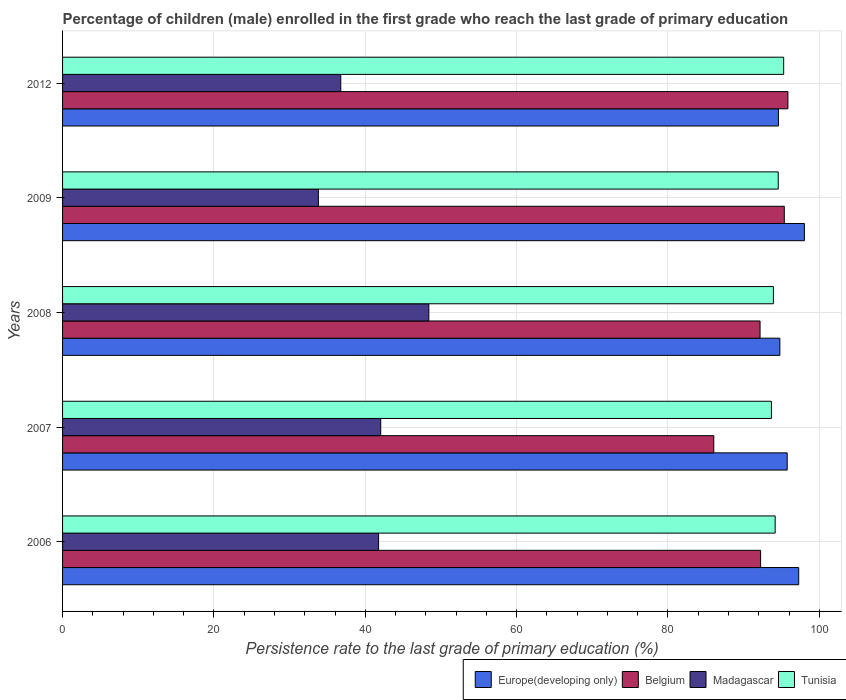How many different coloured bars are there?
Keep it short and to the point. 4. How many groups of bars are there?
Provide a short and direct response. 5. Are the number of bars per tick equal to the number of legend labels?
Give a very brief answer. Yes. What is the label of the 5th group of bars from the top?
Ensure brevity in your answer.  2006. In how many cases, is the number of bars for a given year not equal to the number of legend labels?
Ensure brevity in your answer.  0. What is the persistence rate of children in Europe(developing only) in 2008?
Give a very brief answer. 94.78. Across all years, what is the maximum persistence rate of children in Europe(developing only)?
Your response must be concise. 98.03. Across all years, what is the minimum persistence rate of children in Madagascar?
Give a very brief answer. 33.8. What is the total persistence rate of children in Europe(developing only) in the graph?
Provide a short and direct response. 480.44. What is the difference between the persistence rate of children in Tunisia in 2006 and that in 2008?
Offer a terse response. 0.23. What is the difference between the persistence rate of children in Europe(developing only) in 2009 and the persistence rate of children in Belgium in 2008?
Give a very brief answer. 5.86. What is the average persistence rate of children in Madagascar per year?
Your answer should be compact. 40.55. In the year 2012, what is the difference between the persistence rate of children in Tunisia and persistence rate of children in Belgium?
Your answer should be compact. -0.56. What is the ratio of the persistence rate of children in Europe(developing only) in 2007 to that in 2012?
Provide a short and direct response. 1.01. What is the difference between the highest and the second highest persistence rate of children in Tunisia?
Offer a very short reply. 0.72. What is the difference between the highest and the lowest persistence rate of children in Tunisia?
Your response must be concise. 1.62. In how many years, is the persistence rate of children in Europe(developing only) greater than the average persistence rate of children in Europe(developing only) taken over all years?
Give a very brief answer. 2. Is the sum of the persistence rate of children in Belgium in 2007 and 2008 greater than the maximum persistence rate of children in Tunisia across all years?
Provide a short and direct response. Yes. What does the 1st bar from the top in 2007 represents?
Keep it short and to the point. Tunisia. What does the 4th bar from the bottom in 2007 represents?
Give a very brief answer. Tunisia. Is it the case that in every year, the sum of the persistence rate of children in Europe(developing only) and persistence rate of children in Belgium is greater than the persistence rate of children in Madagascar?
Give a very brief answer. Yes. How many years are there in the graph?
Offer a very short reply. 5. Where does the legend appear in the graph?
Provide a short and direct response. Bottom right. How many legend labels are there?
Keep it short and to the point. 4. How are the legend labels stacked?
Make the answer very short. Horizontal. What is the title of the graph?
Your response must be concise. Percentage of children (male) enrolled in the first grade who reach the last grade of primary education. Does "Japan" appear as one of the legend labels in the graph?
Provide a succinct answer. No. What is the label or title of the X-axis?
Your response must be concise. Persistence rate to the last grade of primary education (%). What is the Persistence rate to the last grade of primary education (%) of Europe(developing only) in 2006?
Offer a terse response. 97.27. What is the Persistence rate to the last grade of primary education (%) of Belgium in 2006?
Provide a succinct answer. 92.24. What is the Persistence rate to the last grade of primary education (%) in Madagascar in 2006?
Your answer should be compact. 41.76. What is the Persistence rate to the last grade of primary education (%) of Tunisia in 2006?
Your answer should be compact. 94.17. What is the Persistence rate to the last grade of primary education (%) in Europe(developing only) in 2007?
Offer a terse response. 95.75. What is the Persistence rate to the last grade of primary education (%) of Belgium in 2007?
Ensure brevity in your answer.  86.05. What is the Persistence rate to the last grade of primary education (%) of Madagascar in 2007?
Ensure brevity in your answer.  42.04. What is the Persistence rate to the last grade of primary education (%) in Tunisia in 2007?
Give a very brief answer. 93.67. What is the Persistence rate to the last grade of primary education (%) in Europe(developing only) in 2008?
Give a very brief answer. 94.78. What is the Persistence rate to the last grade of primary education (%) in Belgium in 2008?
Offer a very short reply. 92.17. What is the Persistence rate to the last grade of primary education (%) of Madagascar in 2008?
Keep it short and to the point. 48.4. What is the Persistence rate to the last grade of primary education (%) of Tunisia in 2008?
Your answer should be compact. 93.93. What is the Persistence rate to the last grade of primary education (%) in Europe(developing only) in 2009?
Ensure brevity in your answer.  98.03. What is the Persistence rate to the last grade of primary education (%) in Belgium in 2009?
Provide a short and direct response. 95.37. What is the Persistence rate to the last grade of primary education (%) of Madagascar in 2009?
Ensure brevity in your answer.  33.8. What is the Persistence rate to the last grade of primary education (%) of Tunisia in 2009?
Give a very brief answer. 94.57. What is the Persistence rate to the last grade of primary education (%) of Europe(developing only) in 2012?
Give a very brief answer. 94.6. What is the Persistence rate to the last grade of primary education (%) in Belgium in 2012?
Make the answer very short. 95.85. What is the Persistence rate to the last grade of primary education (%) of Madagascar in 2012?
Offer a terse response. 36.76. What is the Persistence rate to the last grade of primary education (%) of Tunisia in 2012?
Offer a terse response. 95.29. Across all years, what is the maximum Persistence rate to the last grade of primary education (%) of Europe(developing only)?
Your answer should be compact. 98.03. Across all years, what is the maximum Persistence rate to the last grade of primary education (%) of Belgium?
Offer a very short reply. 95.85. Across all years, what is the maximum Persistence rate to the last grade of primary education (%) of Madagascar?
Give a very brief answer. 48.4. Across all years, what is the maximum Persistence rate to the last grade of primary education (%) in Tunisia?
Make the answer very short. 95.29. Across all years, what is the minimum Persistence rate to the last grade of primary education (%) in Europe(developing only)?
Your answer should be compact. 94.6. Across all years, what is the minimum Persistence rate to the last grade of primary education (%) of Belgium?
Give a very brief answer. 86.05. Across all years, what is the minimum Persistence rate to the last grade of primary education (%) in Madagascar?
Make the answer very short. 33.8. Across all years, what is the minimum Persistence rate to the last grade of primary education (%) in Tunisia?
Ensure brevity in your answer.  93.67. What is the total Persistence rate to the last grade of primary education (%) in Europe(developing only) in the graph?
Give a very brief answer. 480.44. What is the total Persistence rate to the last grade of primary education (%) in Belgium in the graph?
Your answer should be compact. 461.68. What is the total Persistence rate to the last grade of primary education (%) in Madagascar in the graph?
Keep it short and to the point. 202.77. What is the total Persistence rate to the last grade of primary education (%) in Tunisia in the graph?
Your answer should be very brief. 471.63. What is the difference between the Persistence rate to the last grade of primary education (%) of Europe(developing only) in 2006 and that in 2007?
Make the answer very short. 1.52. What is the difference between the Persistence rate to the last grade of primary education (%) in Belgium in 2006 and that in 2007?
Ensure brevity in your answer.  6.19. What is the difference between the Persistence rate to the last grade of primary education (%) in Madagascar in 2006 and that in 2007?
Provide a short and direct response. -0.28. What is the difference between the Persistence rate to the last grade of primary education (%) of Tunisia in 2006 and that in 2007?
Offer a terse response. 0.5. What is the difference between the Persistence rate to the last grade of primary education (%) of Europe(developing only) in 2006 and that in 2008?
Offer a terse response. 2.49. What is the difference between the Persistence rate to the last grade of primary education (%) in Belgium in 2006 and that in 2008?
Provide a short and direct response. 0.07. What is the difference between the Persistence rate to the last grade of primary education (%) of Madagascar in 2006 and that in 2008?
Offer a terse response. -6.64. What is the difference between the Persistence rate to the last grade of primary education (%) in Tunisia in 2006 and that in 2008?
Provide a short and direct response. 0.23. What is the difference between the Persistence rate to the last grade of primary education (%) of Europe(developing only) in 2006 and that in 2009?
Your response must be concise. -0.75. What is the difference between the Persistence rate to the last grade of primary education (%) in Belgium in 2006 and that in 2009?
Keep it short and to the point. -3.13. What is the difference between the Persistence rate to the last grade of primary education (%) in Madagascar in 2006 and that in 2009?
Offer a terse response. 7.96. What is the difference between the Persistence rate to the last grade of primary education (%) of Tunisia in 2006 and that in 2009?
Offer a very short reply. -0.4. What is the difference between the Persistence rate to the last grade of primary education (%) of Europe(developing only) in 2006 and that in 2012?
Your answer should be very brief. 2.68. What is the difference between the Persistence rate to the last grade of primary education (%) of Belgium in 2006 and that in 2012?
Keep it short and to the point. -3.61. What is the difference between the Persistence rate to the last grade of primary education (%) in Madagascar in 2006 and that in 2012?
Offer a very short reply. 5. What is the difference between the Persistence rate to the last grade of primary education (%) of Tunisia in 2006 and that in 2012?
Keep it short and to the point. -1.12. What is the difference between the Persistence rate to the last grade of primary education (%) of Europe(developing only) in 2007 and that in 2008?
Provide a short and direct response. 0.97. What is the difference between the Persistence rate to the last grade of primary education (%) of Belgium in 2007 and that in 2008?
Offer a very short reply. -6.11. What is the difference between the Persistence rate to the last grade of primary education (%) of Madagascar in 2007 and that in 2008?
Ensure brevity in your answer.  -6.36. What is the difference between the Persistence rate to the last grade of primary education (%) in Tunisia in 2007 and that in 2008?
Ensure brevity in your answer.  -0.26. What is the difference between the Persistence rate to the last grade of primary education (%) of Europe(developing only) in 2007 and that in 2009?
Your response must be concise. -2.27. What is the difference between the Persistence rate to the last grade of primary education (%) in Belgium in 2007 and that in 2009?
Ensure brevity in your answer.  -9.32. What is the difference between the Persistence rate to the last grade of primary education (%) in Madagascar in 2007 and that in 2009?
Make the answer very short. 8.24. What is the difference between the Persistence rate to the last grade of primary education (%) in Tunisia in 2007 and that in 2009?
Keep it short and to the point. -0.9. What is the difference between the Persistence rate to the last grade of primary education (%) in Europe(developing only) in 2007 and that in 2012?
Your answer should be very brief. 1.16. What is the difference between the Persistence rate to the last grade of primary education (%) in Belgium in 2007 and that in 2012?
Offer a terse response. -9.8. What is the difference between the Persistence rate to the last grade of primary education (%) in Madagascar in 2007 and that in 2012?
Give a very brief answer. 5.28. What is the difference between the Persistence rate to the last grade of primary education (%) of Tunisia in 2007 and that in 2012?
Ensure brevity in your answer.  -1.62. What is the difference between the Persistence rate to the last grade of primary education (%) in Europe(developing only) in 2008 and that in 2009?
Keep it short and to the point. -3.24. What is the difference between the Persistence rate to the last grade of primary education (%) of Belgium in 2008 and that in 2009?
Make the answer very short. -3.2. What is the difference between the Persistence rate to the last grade of primary education (%) in Madagascar in 2008 and that in 2009?
Provide a short and direct response. 14.6. What is the difference between the Persistence rate to the last grade of primary education (%) of Tunisia in 2008 and that in 2009?
Make the answer very short. -0.64. What is the difference between the Persistence rate to the last grade of primary education (%) of Europe(developing only) in 2008 and that in 2012?
Keep it short and to the point. 0.19. What is the difference between the Persistence rate to the last grade of primary education (%) in Belgium in 2008 and that in 2012?
Give a very brief answer. -3.68. What is the difference between the Persistence rate to the last grade of primary education (%) in Madagascar in 2008 and that in 2012?
Offer a very short reply. 11.64. What is the difference between the Persistence rate to the last grade of primary education (%) of Tunisia in 2008 and that in 2012?
Keep it short and to the point. -1.36. What is the difference between the Persistence rate to the last grade of primary education (%) in Europe(developing only) in 2009 and that in 2012?
Give a very brief answer. 3.43. What is the difference between the Persistence rate to the last grade of primary education (%) of Belgium in 2009 and that in 2012?
Your response must be concise. -0.48. What is the difference between the Persistence rate to the last grade of primary education (%) in Madagascar in 2009 and that in 2012?
Keep it short and to the point. -2.96. What is the difference between the Persistence rate to the last grade of primary education (%) in Tunisia in 2009 and that in 2012?
Provide a short and direct response. -0.72. What is the difference between the Persistence rate to the last grade of primary education (%) in Europe(developing only) in 2006 and the Persistence rate to the last grade of primary education (%) in Belgium in 2007?
Provide a short and direct response. 11.22. What is the difference between the Persistence rate to the last grade of primary education (%) of Europe(developing only) in 2006 and the Persistence rate to the last grade of primary education (%) of Madagascar in 2007?
Ensure brevity in your answer.  55.23. What is the difference between the Persistence rate to the last grade of primary education (%) in Europe(developing only) in 2006 and the Persistence rate to the last grade of primary education (%) in Tunisia in 2007?
Your answer should be compact. 3.6. What is the difference between the Persistence rate to the last grade of primary education (%) of Belgium in 2006 and the Persistence rate to the last grade of primary education (%) of Madagascar in 2007?
Offer a very short reply. 50.2. What is the difference between the Persistence rate to the last grade of primary education (%) of Belgium in 2006 and the Persistence rate to the last grade of primary education (%) of Tunisia in 2007?
Your response must be concise. -1.43. What is the difference between the Persistence rate to the last grade of primary education (%) of Madagascar in 2006 and the Persistence rate to the last grade of primary education (%) of Tunisia in 2007?
Give a very brief answer. -51.91. What is the difference between the Persistence rate to the last grade of primary education (%) in Europe(developing only) in 2006 and the Persistence rate to the last grade of primary education (%) in Belgium in 2008?
Offer a very short reply. 5.11. What is the difference between the Persistence rate to the last grade of primary education (%) of Europe(developing only) in 2006 and the Persistence rate to the last grade of primary education (%) of Madagascar in 2008?
Your answer should be compact. 48.87. What is the difference between the Persistence rate to the last grade of primary education (%) of Europe(developing only) in 2006 and the Persistence rate to the last grade of primary education (%) of Tunisia in 2008?
Offer a very short reply. 3.34. What is the difference between the Persistence rate to the last grade of primary education (%) of Belgium in 2006 and the Persistence rate to the last grade of primary education (%) of Madagascar in 2008?
Ensure brevity in your answer.  43.84. What is the difference between the Persistence rate to the last grade of primary education (%) of Belgium in 2006 and the Persistence rate to the last grade of primary education (%) of Tunisia in 2008?
Give a very brief answer. -1.69. What is the difference between the Persistence rate to the last grade of primary education (%) in Madagascar in 2006 and the Persistence rate to the last grade of primary education (%) in Tunisia in 2008?
Provide a short and direct response. -52.17. What is the difference between the Persistence rate to the last grade of primary education (%) in Europe(developing only) in 2006 and the Persistence rate to the last grade of primary education (%) in Belgium in 2009?
Offer a terse response. 1.9. What is the difference between the Persistence rate to the last grade of primary education (%) of Europe(developing only) in 2006 and the Persistence rate to the last grade of primary education (%) of Madagascar in 2009?
Your answer should be very brief. 63.47. What is the difference between the Persistence rate to the last grade of primary education (%) of Europe(developing only) in 2006 and the Persistence rate to the last grade of primary education (%) of Tunisia in 2009?
Offer a very short reply. 2.7. What is the difference between the Persistence rate to the last grade of primary education (%) of Belgium in 2006 and the Persistence rate to the last grade of primary education (%) of Madagascar in 2009?
Provide a succinct answer. 58.44. What is the difference between the Persistence rate to the last grade of primary education (%) of Belgium in 2006 and the Persistence rate to the last grade of primary education (%) of Tunisia in 2009?
Your answer should be compact. -2.33. What is the difference between the Persistence rate to the last grade of primary education (%) in Madagascar in 2006 and the Persistence rate to the last grade of primary education (%) in Tunisia in 2009?
Provide a short and direct response. -52.81. What is the difference between the Persistence rate to the last grade of primary education (%) of Europe(developing only) in 2006 and the Persistence rate to the last grade of primary education (%) of Belgium in 2012?
Make the answer very short. 1.43. What is the difference between the Persistence rate to the last grade of primary education (%) in Europe(developing only) in 2006 and the Persistence rate to the last grade of primary education (%) in Madagascar in 2012?
Provide a short and direct response. 60.51. What is the difference between the Persistence rate to the last grade of primary education (%) of Europe(developing only) in 2006 and the Persistence rate to the last grade of primary education (%) of Tunisia in 2012?
Give a very brief answer. 1.99. What is the difference between the Persistence rate to the last grade of primary education (%) in Belgium in 2006 and the Persistence rate to the last grade of primary education (%) in Madagascar in 2012?
Provide a succinct answer. 55.48. What is the difference between the Persistence rate to the last grade of primary education (%) in Belgium in 2006 and the Persistence rate to the last grade of primary education (%) in Tunisia in 2012?
Provide a short and direct response. -3.05. What is the difference between the Persistence rate to the last grade of primary education (%) of Madagascar in 2006 and the Persistence rate to the last grade of primary education (%) of Tunisia in 2012?
Your answer should be very brief. -53.53. What is the difference between the Persistence rate to the last grade of primary education (%) in Europe(developing only) in 2007 and the Persistence rate to the last grade of primary education (%) in Belgium in 2008?
Keep it short and to the point. 3.59. What is the difference between the Persistence rate to the last grade of primary education (%) of Europe(developing only) in 2007 and the Persistence rate to the last grade of primary education (%) of Madagascar in 2008?
Keep it short and to the point. 47.35. What is the difference between the Persistence rate to the last grade of primary education (%) of Europe(developing only) in 2007 and the Persistence rate to the last grade of primary education (%) of Tunisia in 2008?
Offer a very short reply. 1.82. What is the difference between the Persistence rate to the last grade of primary education (%) in Belgium in 2007 and the Persistence rate to the last grade of primary education (%) in Madagascar in 2008?
Give a very brief answer. 37.65. What is the difference between the Persistence rate to the last grade of primary education (%) of Belgium in 2007 and the Persistence rate to the last grade of primary education (%) of Tunisia in 2008?
Your response must be concise. -7.88. What is the difference between the Persistence rate to the last grade of primary education (%) in Madagascar in 2007 and the Persistence rate to the last grade of primary education (%) in Tunisia in 2008?
Provide a short and direct response. -51.89. What is the difference between the Persistence rate to the last grade of primary education (%) of Europe(developing only) in 2007 and the Persistence rate to the last grade of primary education (%) of Belgium in 2009?
Ensure brevity in your answer.  0.38. What is the difference between the Persistence rate to the last grade of primary education (%) in Europe(developing only) in 2007 and the Persistence rate to the last grade of primary education (%) in Madagascar in 2009?
Keep it short and to the point. 61.95. What is the difference between the Persistence rate to the last grade of primary education (%) of Europe(developing only) in 2007 and the Persistence rate to the last grade of primary education (%) of Tunisia in 2009?
Your response must be concise. 1.18. What is the difference between the Persistence rate to the last grade of primary education (%) of Belgium in 2007 and the Persistence rate to the last grade of primary education (%) of Madagascar in 2009?
Your answer should be very brief. 52.25. What is the difference between the Persistence rate to the last grade of primary education (%) in Belgium in 2007 and the Persistence rate to the last grade of primary education (%) in Tunisia in 2009?
Offer a very short reply. -8.52. What is the difference between the Persistence rate to the last grade of primary education (%) of Madagascar in 2007 and the Persistence rate to the last grade of primary education (%) of Tunisia in 2009?
Give a very brief answer. -52.53. What is the difference between the Persistence rate to the last grade of primary education (%) in Europe(developing only) in 2007 and the Persistence rate to the last grade of primary education (%) in Belgium in 2012?
Your answer should be compact. -0.09. What is the difference between the Persistence rate to the last grade of primary education (%) of Europe(developing only) in 2007 and the Persistence rate to the last grade of primary education (%) of Madagascar in 2012?
Your answer should be very brief. 58.99. What is the difference between the Persistence rate to the last grade of primary education (%) of Europe(developing only) in 2007 and the Persistence rate to the last grade of primary education (%) of Tunisia in 2012?
Give a very brief answer. 0.47. What is the difference between the Persistence rate to the last grade of primary education (%) in Belgium in 2007 and the Persistence rate to the last grade of primary education (%) in Madagascar in 2012?
Give a very brief answer. 49.29. What is the difference between the Persistence rate to the last grade of primary education (%) of Belgium in 2007 and the Persistence rate to the last grade of primary education (%) of Tunisia in 2012?
Keep it short and to the point. -9.24. What is the difference between the Persistence rate to the last grade of primary education (%) in Madagascar in 2007 and the Persistence rate to the last grade of primary education (%) in Tunisia in 2012?
Your answer should be compact. -53.25. What is the difference between the Persistence rate to the last grade of primary education (%) in Europe(developing only) in 2008 and the Persistence rate to the last grade of primary education (%) in Belgium in 2009?
Your answer should be compact. -0.59. What is the difference between the Persistence rate to the last grade of primary education (%) of Europe(developing only) in 2008 and the Persistence rate to the last grade of primary education (%) of Madagascar in 2009?
Ensure brevity in your answer.  60.98. What is the difference between the Persistence rate to the last grade of primary education (%) of Europe(developing only) in 2008 and the Persistence rate to the last grade of primary education (%) of Tunisia in 2009?
Ensure brevity in your answer.  0.21. What is the difference between the Persistence rate to the last grade of primary education (%) of Belgium in 2008 and the Persistence rate to the last grade of primary education (%) of Madagascar in 2009?
Offer a very short reply. 58.36. What is the difference between the Persistence rate to the last grade of primary education (%) of Belgium in 2008 and the Persistence rate to the last grade of primary education (%) of Tunisia in 2009?
Your answer should be very brief. -2.4. What is the difference between the Persistence rate to the last grade of primary education (%) of Madagascar in 2008 and the Persistence rate to the last grade of primary education (%) of Tunisia in 2009?
Provide a short and direct response. -46.17. What is the difference between the Persistence rate to the last grade of primary education (%) of Europe(developing only) in 2008 and the Persistence rate to the last grade of primary education (%) of Belgium in 2012?
Give a very brief answer. -1.06. What is the difference between the Persistence rate to the last grade of primary education (%) in Europe(developing only) in 2008 and the Persistence rate to the last grade of primary education (%) in Madagascar in 2012?
Your answer should be very brief. 58.02. What is the difference between the Persistence rate to the last grade of primary education (%) in Europe(developing only) in 2008 and the Persistence rate to the last grade of primary education (%) in Tunisia in 2012?
Your response must be concise. -0.51. What is the difference between the Persistence rate to the last grade of primary education (%) in Belgium in 2008 and the Persistence rate to the last grade of primary education (%) in Madagascar in 2012?
Ensure brevity in your answer.  55.41. What is the difference between the Persistence rate to the last grade of primary education (%) of Belgium in 2008 and the Persistence rate to the last grade of primary education (%) of Tunisia in 2012?
Offer a very short reply. -3.12. What is the difference between the Persistence rate to the last grade of primary education (%) of Madagascar in 2008 and the Persistence rate to the last grade of primary education (%) of Tunisia in 2012?
Your response must be concise. -46.89. What is the difference between the Persistence rate to the last grade of primary education (%) in Europe(developing only) in 2009 and the Persistence rate to the last grade of primary education (%) in Belgium in 2012?
Ensure brevity in your answer.  2.18. What is the difference between the Persistence rate to the last grade of primary education (%) of Europe(developing only) in 2009 and the Persistence rate to the last grade of primary education (%) of Madagascar in 2012?
Ensure brevity in your answer.  61.26. What is the difference between the Persistence rate to the last grade of primary education (%) in Europe(developing only) in 2009 and the Persistence rate to the last grade of primary education (%) in Tunisia in 2012?
Ensure brevity in your answer.  2.74. What is the difference between the Persistence rate to the last grade of primary education (%) of Belgium in 2009 and the Persistence rate to the last grade of primary education (%) of Madagascar in 2012?
Keep it short and to the point. 58.61. What is the difference between the Persistence rate to the last grade of primary education (%) in Belgium in 2009 and the Persistence rate to the last grade of primary education (%) in Tunisia in 2012?
Your response must be concise. 0.08. What is the difference between the Persistence rate to the last grade of primary education (%) in Madagascar in 2009 and the Persistence rate to the last grade of primary education (%) in Tunisia in 2012?
Your answer should be compact. -61.48. What is the average Persistence rate to the last grade of primary education (%) in Europe(developing only) per year?
Offer a terse response. 96.09. What is the average Persistence rate to the last grade of primary education (%) in Belgium per year?
Keep it short and to the point. 92.34. What is the average Persistence rate to the last grade of primary education (%) in Madagascar per year?
Your answer should be compact. 40.55. What is the average Persistence rate to the last grade of primary education (%) of Tunisia per year?
Your answer should be compact. 94.33. In the year 2006, what is the difference between the Persistence rate to the last grade of primary education (%) of Europe(developing only) and Persistence rate to the last grade of primary education (%) of Belgium?
Keep it short and to the point. 5.03. In the year 2006, what is the difference between the Persistence rate to the last grade of primary education (%) of Europe(developing only) and Persistence rate to the last grade of primary education (%) of Madagascar?
Ensure brevity in your answer.  55.51. In the year 2006, what is the difference between the Persistence rate to the last grade of primary education (%) in Europe(developing only) and Persistence rate to the last grade of primary education (%) in Tunisia?
Your answer should be very brief. 3.11. In the year 2006, what is the difference between the Persistence rate to the last grade of primary education (%) of Belgium and Persistence rate to the last grade of primary education (%) of Madagascar?
Your answer should be very brief. 50.48. In the year 2006, what is the difference between the Persistence rate to the last grade of primary education (%) of Belgium and Persistence rate to the last grade of primary education (%) of Tunisia?
Provide a short and direct response. -1.92. In the year 2006, what is the difference between the Persistence rate to the last grade of primary education (%) in Madagascar and Persistence rate to the last grade of primary education (%) in Tunisia?
Offer a very short reply. -52.41. In the year 2007, what is the difference between the Persistence rate to the last grade of primary education (%) of Europe(developing only) and Persistence rate to the last grade of primary education (%) of Belgium?
Offer a very short reply. 9.7. In the year 2007, what is the difference between the Persistence rate to the last grade of primary education (%) of Europe(developing only) and Persistence rate to the last grade of primary education (%) of Madagascar?
Give a very brief answer. 53.71. In the year 2007, what is the difference between the Persistence rate to the last grade of primary education (%) in Europe(developing only) and Persistence rate to the last grade of primary education (%) in Tunisia?
Offer a terse response. 2.09. In the year 2007, what is the difference between the Persistence rate to the last grade of primary education (%) of Belgium and Persistence rate to the last grade of primary education (%) of Madagascar?
Your answer should be compact. 44.01. In the year 2007, what is the difference between the Persistence rate to the last grade of primary education (%) in Belgium and Persistence rate to the last grade of primary education (%) in Tunisia?
Offer a terse response. -7.62. In the year 2007, what is the difference between the Persistence rate to the last grade of primary education (%) of Madagascar and Persistence rate to the last grade of primary education (%) of Tunisia?
Offer a very short reply. -51.63. In the year 2008, what is the difference between the Persistence rate to the last grade of primary education (%) in Europe(developing only) and Persistence rate to the last grade of primary education (%) in Belgium?
Provide a succinct answer. 2.62. In the year 2008, what is the difference between the Persistence rate to the last grade of primary education (%) of Europe(developing only) and Persistence rate to the last grade of primary education (%) of Madagascar?
Your answer should be compact. 46.38. In the year 2008, what is the difference between the Persistence rate to the last grade of primary education (%) in Europe(developing only) and Persistence rate to the last grade of primary education (%) in Tunisia?
Provide a succinct answer. 0.85. In the year 2008, what is the difference between the Persistence rate to the last grade of primary education (%) of Belgium and Persistence rate to the last grade of primary education (%) of Madagascar?
Provide a short and direct response. 43.77. In the year 2008, what is the difference between the Persistence rate to the last grade of primary education (%) of Belgium and Persistence rate to the last grade of primary education (%) of Tunisia?
Make the answer very short. -1.76. In the year 2008, what is the difference between the Persistence rate to the last grade of primary education (%) of Madagascar and Persistence rate to the last grade of primary education (%) of Tunisia?
Your response must be concise. -45.53. In the year 2009, what is the difference between the Persistence rate to the last grade of primary education (%) of Europe(developing only) and Persistence rate to the last grade of primary education (%) of Belgium?
Your response must be concise. 2.66. In the year 2009, what is the difference between the Persistence rate to the last grade of primary education (%) in Europe(developing only) and Persistence rate to the last grade of primary education (%) in Madagascar?
Give a very brief answer. 64.22. In the year 2009, what is the difference between the Persistence rate to the last grade of primary education (%) in Europe(developing only) and Persistence rate to the last grade of primary education (%) in Tunisia?
Provide a short and direct response. 3.46. In the year 2009, what is the difference between the Persistence rate to the last grade of primary education (%) of Belgium and Persistence rate to the last grade of primary education (%) of Madagascar?
Give a very brief answer. 61.57. In the year 2009, what is the difference between the Persistence rate to the last grade of primary education (%) in Belgium and Persistence rate to the last grade of primary education (%) in Tunisia?
Provide a short and direct response. 0.8. In the year 2009, what is the difference between the Persistence rate to the last grade of primary education (%) in Madagascar and Persistence rate to the last grade of primary education (%) in Tunisia?
Keep it short and to the point. -60.77. In the year 2012, what is the difference between the Persistence rate to the last grade of primary education (%) in Europe(developing only) and Persistence rate to the last grade of primary education (%) in Belgium?
Your response must be concise. -1.25. In the year 2012, what is the difference between the Persistence rate to the last grade of primary education (%) of Europe(developing only) and Persistence rate to the last grade of primary education (%) of Madagascar?
Keep it short and to the point. 57.84. In the year 2012, what is the difference between the Persistence rate to the last grade of primary education (%) of Europe(developing only) and Persistence rate to the last grade of primary education (%) of Tunisia?
Ensure brevity in your answer.  -0.69. In the year 2012, what is the difference between the Persistence rate to the last grade of primary education (%) of Belgium and Persistence rate to the last grade of primary education (%) of Madagascar?
Offer a very short reply. 59.09. In the year 2012, what is the difference between the Persistence rate to the last grade of primary education (%) in Belgium and Persistence rate to the last grade of primary education (%) in Tunisia?
Offer a terse response. 0.56. In the year 2012, what is the difference between the Persistence rate to the last grade of primary education (%) of Madagascar and Persistence rate to the last grade of primary education (%) of Tunisia?
Keep it short and to the point. -58.53. What is the ratio of the Persistence rate to the last grade of primary education (%) in Europe(developing only) in 2006 to that in 2007?
Ensure brevity in your answer.  1.02. What is the ratio of the Persistence rate to the last grade of primary education (%) in Belgium in 2006 to that in 2007?
Offer a terse response. 1.07. What is the ratio of the Persistence rate to the last grade of primary education (%) of Madagascar in 2006 to that in 2007?
Give a very brief answer. 0.99. What is the ratio of the Persistence rate to the last grade of primary education (%) of Europe(developing only) in 2006 to that in 2008?
Provide a short and direct response. 1.03. What is the ratio of the Persistence rate to the last grade of primary education (%) of Belgium in 2006 to that in 2008?
Offer a terse response. 1. What is the ratio of the Persistence rate to the last grade of primary education (%) of Madagascar in 2006 to that in 2008?
Provide a short and direct response. 0.86. What is the ratio of the Persistence rate to the last grade of primary education (%) in Tunisia in 2006 to that in 2008?
Your answer should be compact. 1. What is the ratio of the Persistence rate to the last grade of primary education (%) in Belgium in 2006 to that in 2009?
Offer a very short reply. 0.97. What is the ratio of the Persistence rate to the last grade of primary education (%) of Madagascar in 2006 to that in 2009?
Provide a short and direct response. 1.24. What is the ratio of the Persistence rate to the last grade of primary education (%) in Europe(developing only) in 2006 to that in 2012?
Offer a terse response. 1.03. What is the ratio of the Persistence rate to the last grade of primary education (%) in Belgium in 2006 to that in 2012?
Your answer should be compact. 0.96. What is the ratio of the Persistence rate to the last grade of primary education (%) in Madagascar in 2006 to that in 2012?
Offer a terse response. 1.14. What is the ratio of the Persistence rate to the last grade of primary education (%) in Tunisia in 2006 to that in 2012?
Give a very brief answer. 0.99. What is the ratio of the Persistence rate to the last grade of primary education (%) of Europe(developing only) in 2007 to that in 2008?
Keep it short and to the point. 1.01. What is the ratio of the Persistence rate to the last grade of primary education (%) in Belgium in 2007 to that in 2008?
Offer a very short reply. 0.93. What is the ratio of the Persistence rate to the last grade of primary education (%) in Madagascar in 2007 to that in 2008?
Ensure brevity in your answer.  0.87. What is the ratio of the Persistence rate to the last grade of primary education (%) of Tunisia in 2007 to that in 2008?
Your answer should be very brief. 1. What is the ratio of the Persistence rate to the last grade of primary education (%) of Europe(developing only) in 2007 to that in 2009?
Your answer should be compact. 0.98. What is the ratio of the Persistence rate to the last grade of primary education (%) in Belgium in 2007 to that in 2009?
Your answer should be compact. 0.9. What is the ratio of the Persistence rate to the last grade of primary education (%) in Madagascar in 2007 to that in 2009?
Provide a succinct answer. 1.24. What is the ratio of the Persistence rate to the last grade of primary education (%) of Tunisia in 2007 to that in 2009?
Your answer should be very brief. 0.99. What is the ratio of the Persistence rate to the last grade of primary education (%) in Europe(developing only) in 2007 to that in 2012?
Make the answer very short. 1.01. What is the ratio of the Persistence rate to the last grade of primary education (%) of Belgium in 2007 to that in 2012?
Your answer should be compact. 0.9. What is the ratio of the Persistence rate to the last grade of primary education (%) of Madagascar in 2007 to that in 2012?
Offer a very short reply. 1.14. What is the ratio of the Persistence rate to the last grade of primary education (%) in Europe(developing only) in 2008 to that in 2009?
Ensure brevity in your answer.  0.97. What is the ratio of the Persistence rate to the last grade of primary education (%) of Belgium in 2008 to that in 2009?
Give a very brief answer. 0.97. What is the ratio of the Persistence rate to the last grade of primary education (%) of Madagascar in 2008 to that in 2009?
Offer a terse response. 1.43. What is the ratio of the Persistence rate to the last grade of primary education (%) of Tunisia in 2008 to that in 2009?
Your response must be concise. 0.99. What is the ratio of the Persistence rate to the last grade of primary education (%) of Europe(developing only) in 2008 to that in 2012?
Make the answer very short. 1. What is the ratio of the Persistence rate to the last grade of primary education (%) of Belgium in 2008 to that in 2012?
Your response must be concise. 0.96. What is the ratio of the Persistence rate to the last grade of primary education (%) in Madagascar in 2008 to that in 2012?
Your answer should be very brief. 1.32. What is the ratio of the Persistence rate to the last grade of primary education (%) of Tunisia in 2008 to that in 2012?
Your answer should be compact. 0.99. What is the ratio of the Persistence rate to the last grade of primary education (%) of Europe(developing only) in 2009 to that in 2012?
Your response must be concise. 1.04. What is the ratio of the Persistence rate to the last grade of primary education (%) in Belgium in 2009 to that in 2012?
Your response must be concise. 0.99. What is the ratio of the Persistence rate to the last grade of primary education (%) of Madagascar in 2009 to that in 2012?
Keep it short and to the point. 0.92. What is the ratio of the Persistence rate to the last grade of primary education (%) of Tunisia in 2009 to that in 2012?
Make the answer very short. 0.99. What is the difference between the highest and the second highest Persistence rate to the last grade of primary education (%) in Europe(developing only)?
Provide a short and direct response. 0.75. What is the difference between the highest and the second highest Persistence rate to the last grade of primary education (%) of Belgium?
Provide a succinct answer. 0.48. What is the difference between the highest and the second highest Persistence rate to the last grade of primary education (%) of Madagascar?
Your answer should be very brief. 6.36. What is the difference between the highest and the second highest Persistence rate to the last grade of primary education (%) of Tunisia?
Provide a short and direct response. 0.72. What is the difference between the highest and the lowest Persistence rate to the last grade of primary education (%) in Europe(developing only)?
Provide a succinct answer. 3.43. What is the difference between the highest and the lowest Persistence rate to the last grade of primary education (%) in Belgium?
Provide a succinct answer. 9.8. What is the difference between the highest and the lowest Persistence rate to the last grade of primary education (%) of Madagascar?
Provide a short and direct response. 14.6. What is the difference between the highest and the lowest Persistence rate to the last grade of primary education (%) in Tunisia?
Provide a short and direct response. 1.62. 